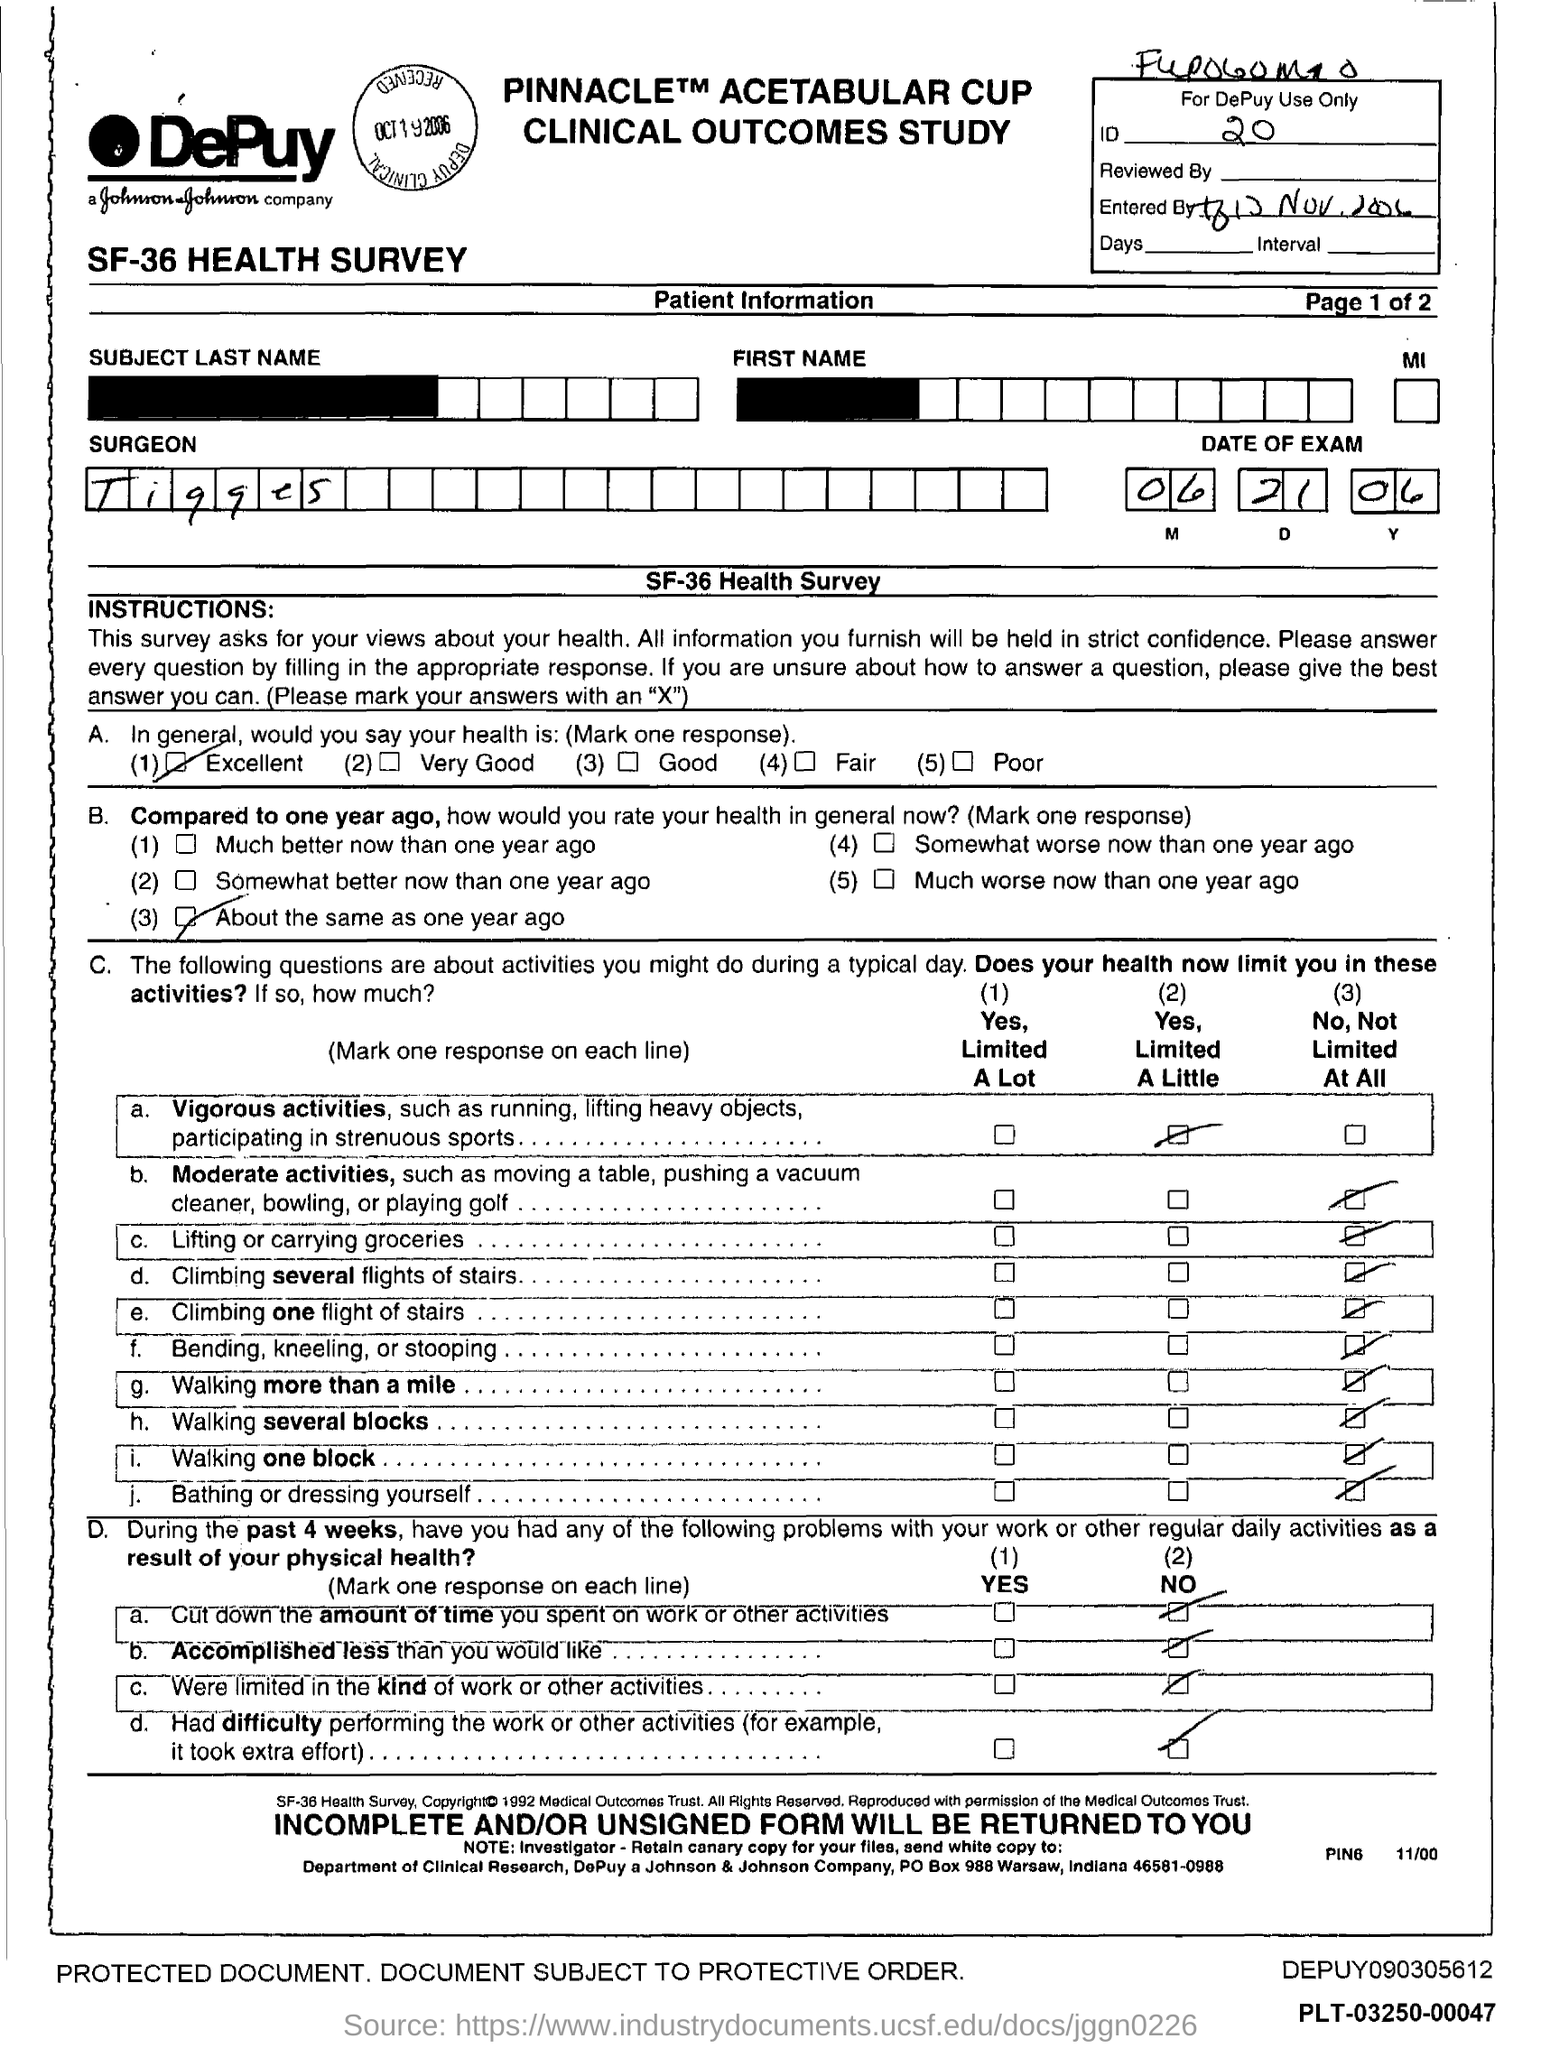Mention a couple of crucial points in this snapshot. The ID mentioned in the form is 20... The date of the exam as specified in the form is June 21, 2006. The surgeon's name mentioned in the form is Tigges. 